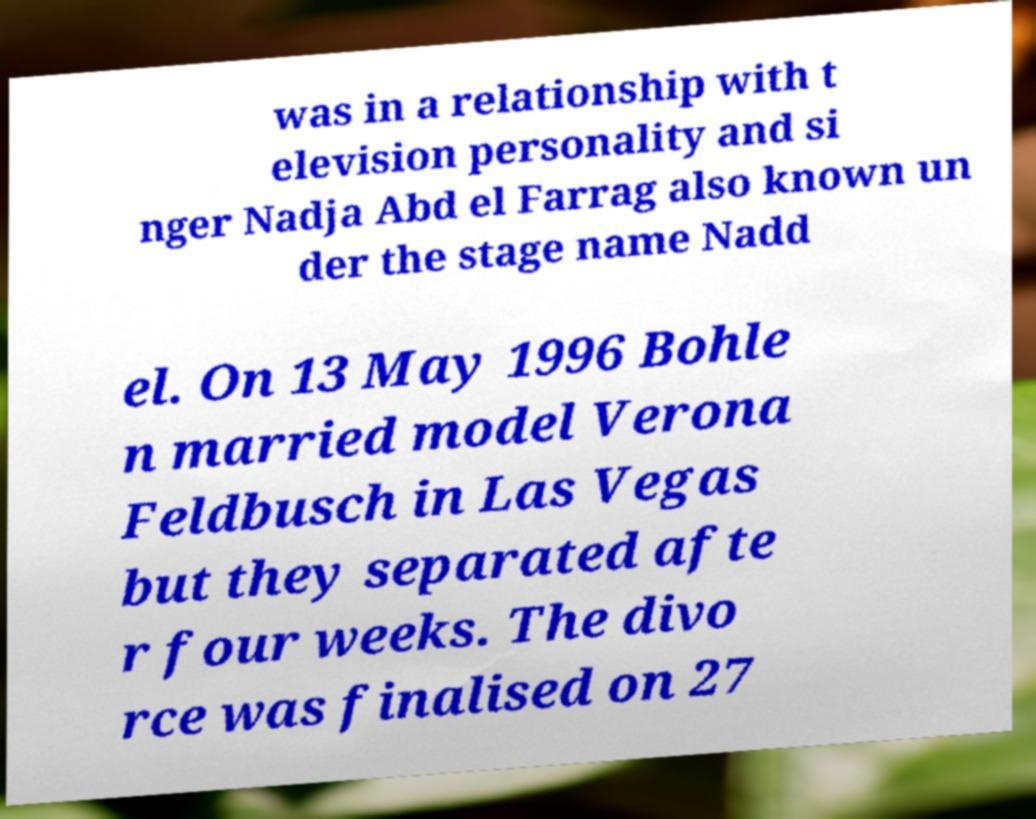For documentation purposes, I need the text within this image transcribed. Could you provide that? was in a relationship with t elevision personality and si nger Nadja Abd el Farrag also known un der the stage name Nadd el. On 13 May 1996 Bohle n married model Verona Feldbusch in Las Vegas but they separated afte r four weeks. The divo rce was finalised on 27 